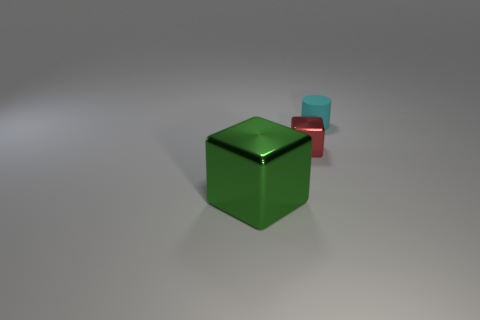Add 1 big green cubes. How many objects exist? 4 Subtract all blocks. How many objects are left? 1 Subtract 0 blue cylinders. How many objects are left? 3 Subtract 1 cylinders. How many cylinders are left? 0 Subtract all brown cylinders. Subtract all cyan cubes. How many cylinders are left? 1 Subtract all brown blocks. How many purple cylinders are left? 0 Subtract all rubber cylinders. Subtract all small blocks. How many objects are left? 1 Add 2 green metal blocks. How many green metal blocks are left? 3 Add 2 red things. How many red things exist? 3 